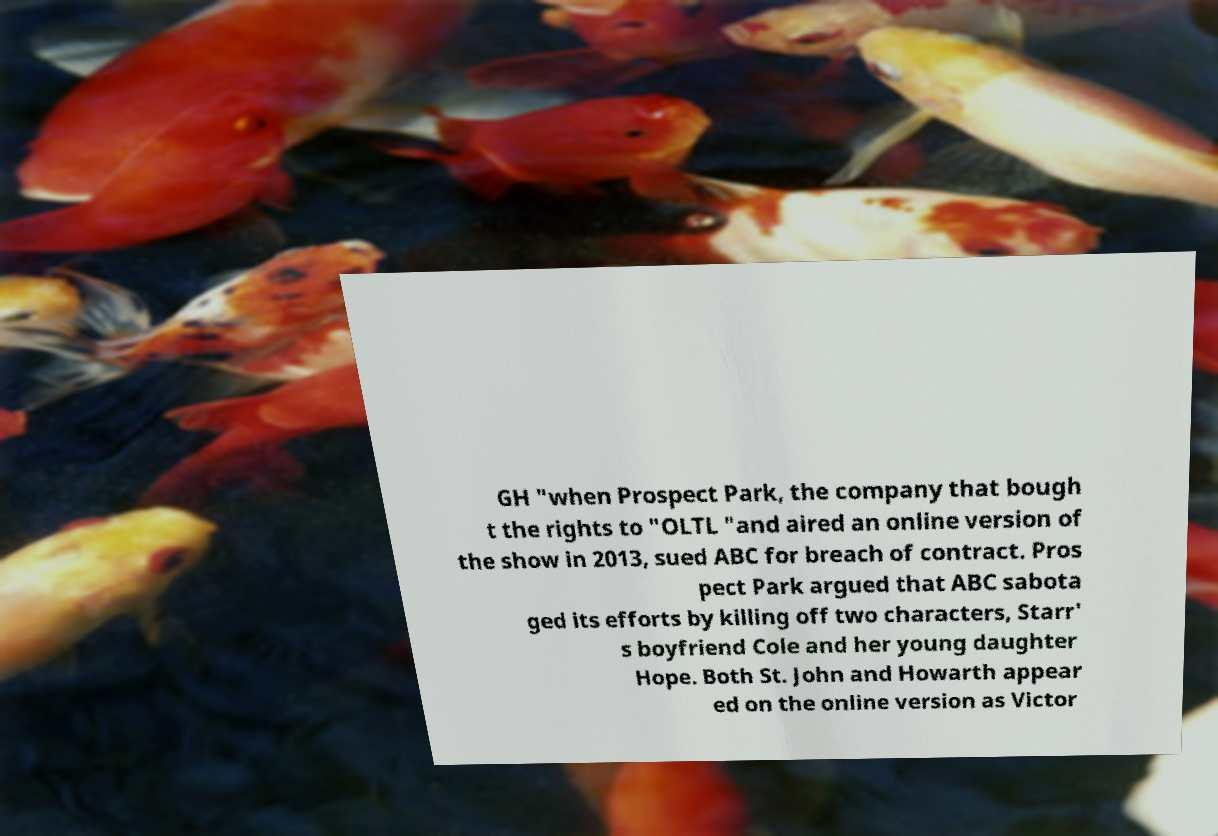What messages or text are displayed in this image? I need them in a readable, typed format. GH "when Prospect Park, the company that bough t the rights to "OLTL "and aired an online version of the show in 2013, sued ABC for breach of contract. Pros pect Park argued that ABC sabota ged its efforts by killing off two characters, Starr' s boyfriend Cole and her young daughter Hope. Both St. John and Howarth appear ed on the online version as Victor 